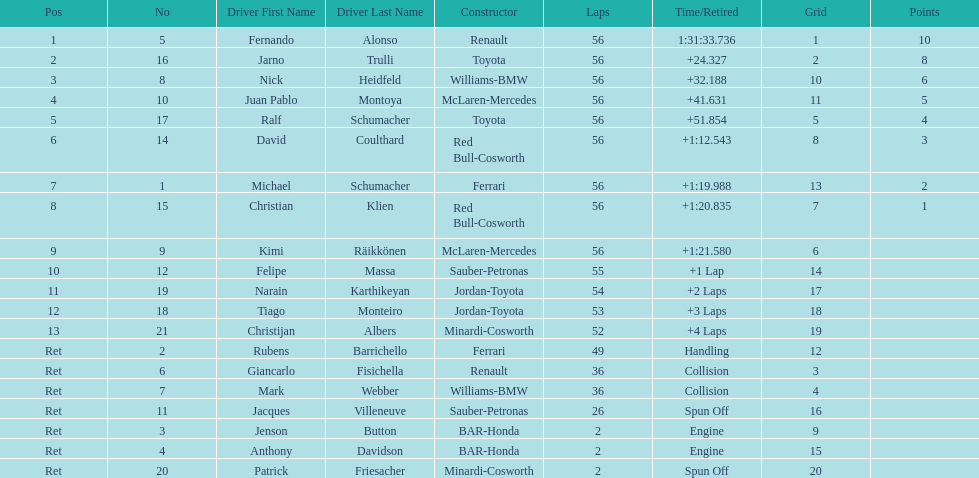How many drivers were retired before the race could end? 7. 